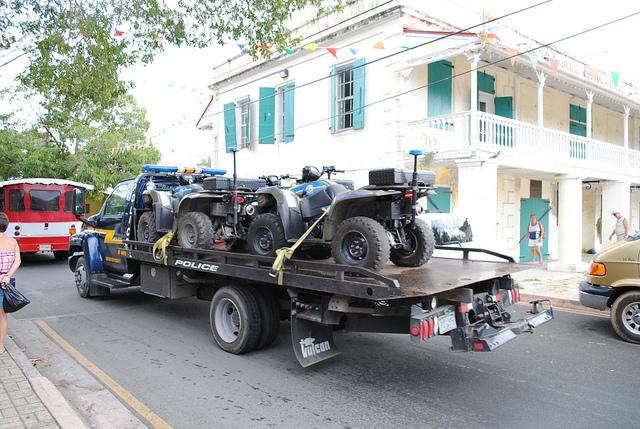Is it daytime?
Concise answer only. Yes. Would this car be considered vintage?
Keep it brief. No. Is this vehicle meant for utility or transportation?
Answer briefly. Utility. What color is the house?
Write a very short answer. White. What's the name on the mud flap?
Be succinct. Vulcan. 